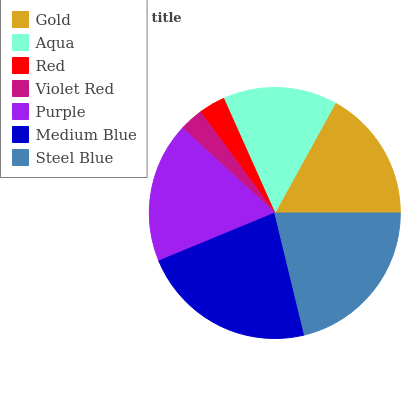Is Violet Red the minimum?
Answer yes or no. Yes. Is Medium Blue the maximum?
Answer yes or no. Yes. Is Aqua the minimum?
Answer yes or no. No. Is Aqua the maximum?
Answer yes or no. No. Is Gold greater than Aqua?
Answer yes or no. Yes. Is Aqua less than Gold?
Answer yes or no. Yes. Is Aqua greater than Gold?
Answer yes or no. No. Is Gold less than Aqua?
Answer yes or no. No. Is Gold the high median?
Answer yes or no. Yes. Is Gold the low median?
Answer yes or no. Yes. Is Red the high median?
Answer yes or no. No. Is Violet Red the low median?
Answer yes or no. No. 